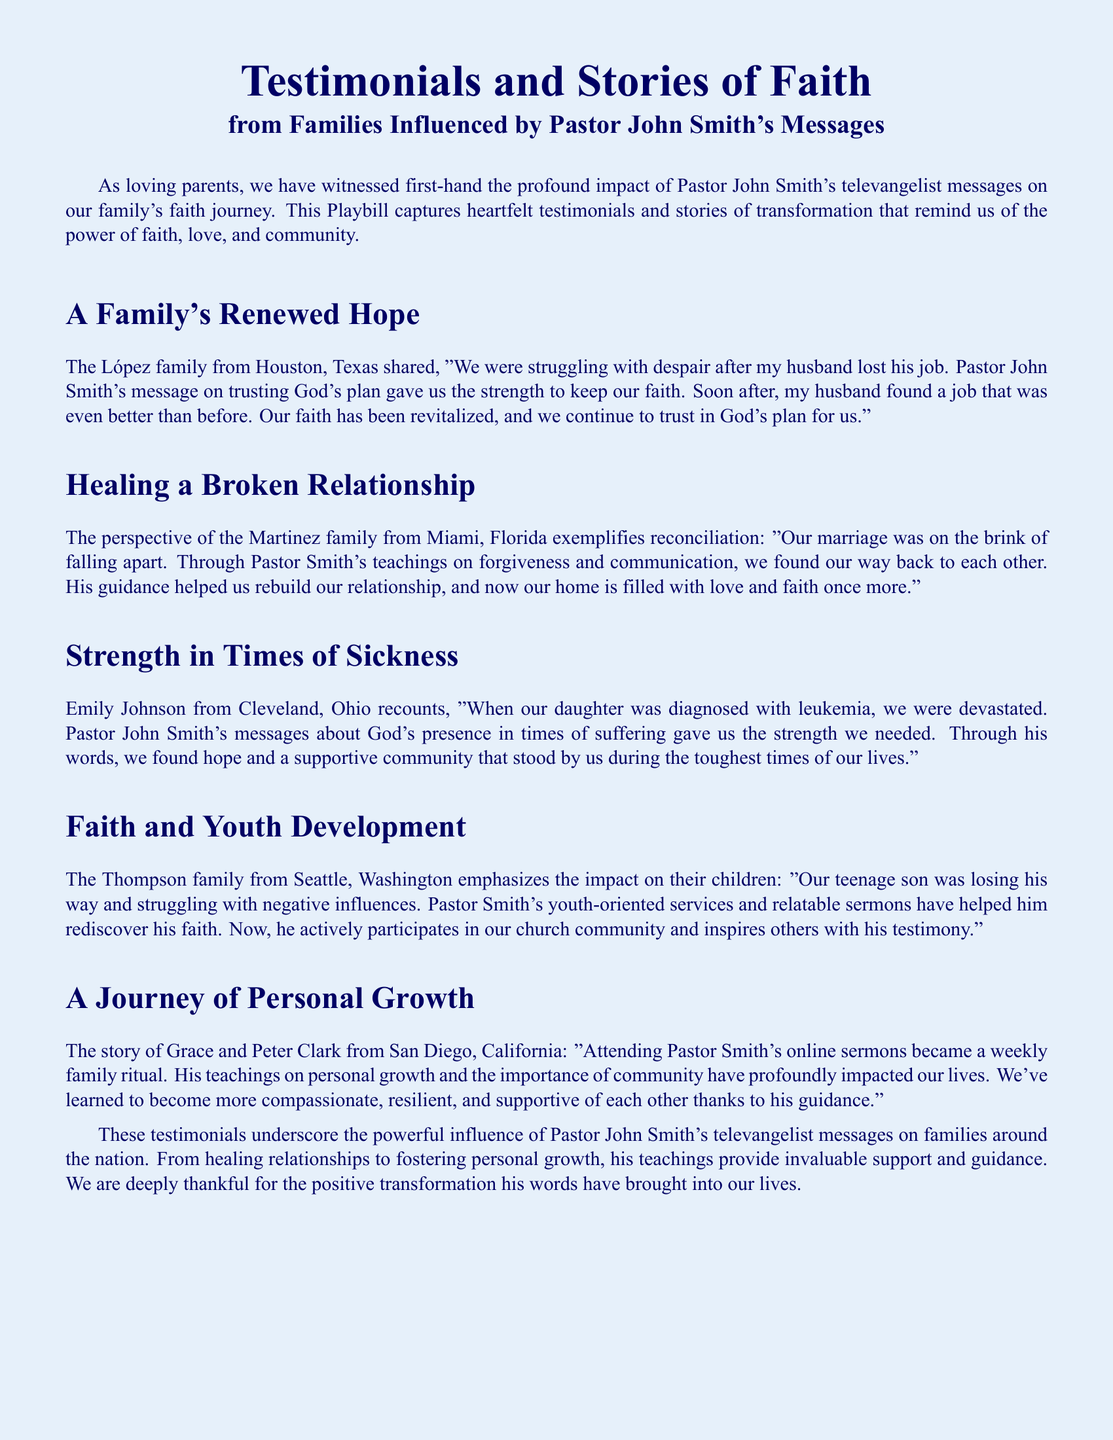What is the title of the document? The title of the document is "Testimonials and Stories of Faith."
Answer: Testimonials and Stories of Faith Who shared their experience of healing a broken relationship? The Martinez family from Miami, Florida shared their experience.
Answer: Martinez family Which family experienced strength during a sickness? Emily Johnson from Cleveland, Ohio recounted their experience.
Answer: Emily Johnson What has been the profession of the husband from the López family? The husband lost his job before finding a new one.
Answer: Job loss Which family emphasizes youth development? The Thompson family from Seattle, Washington emphasizes youth development.
Answer: Thompson family What was the impact of Pastor Smith's teachings on the Lopez family? The Lopez family found strength to keep their faith.
Answer: Strength to keep faith How did Pastor Smith influence the Thompson family's son? He helped him rediscover his faith.
Answer: Rediscover faith What is described as a weekly family ritual for Grace and Peter Clark? Attending Pastor Smith's online sermons.
Answer: Online sermons What type of messages did Pastor John Smith provide during tough times? Messages about God's presence in times of suffering.
Answer: God's presence messages 